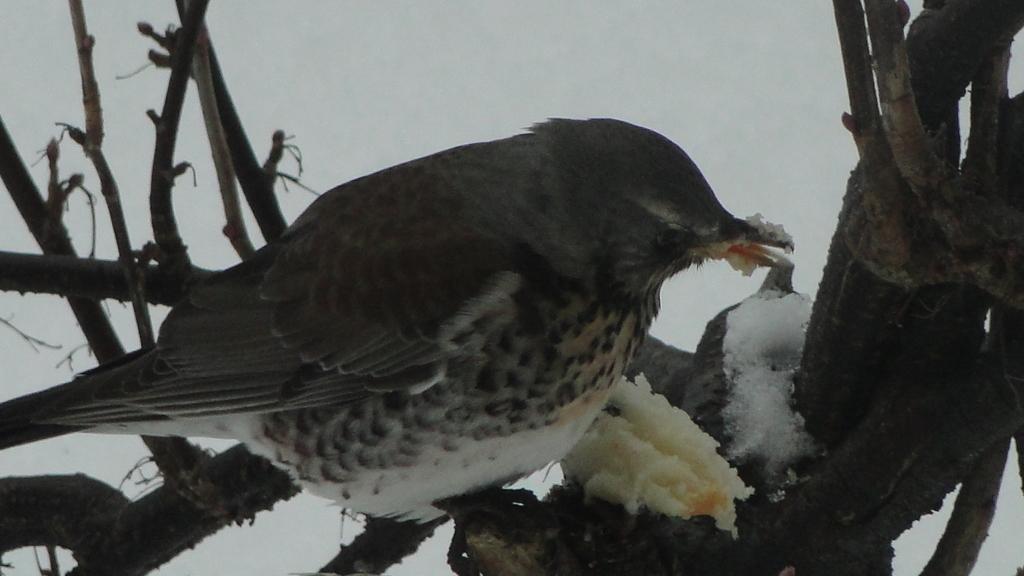How would you summarize this image in a sentence or two? In this image in the foreground there is one bird on the nest, and the bird is eating some food and in the background it looks like a snow. 